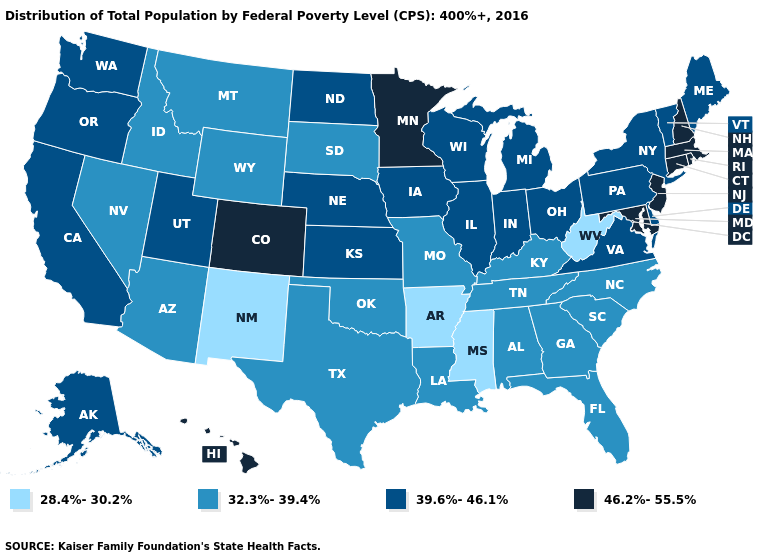How many symbols are there in the legend?
Quick response, please. 4. Among the states that border Colorado , which have the lowest value?
Give a very brief answer. New Mexico. What is the highest value in states that border Nebraska?
Be succinct. 46.2%-55.5%. Name the states that have a value in the range 46.2%-55.5%?
Concise answer only. Colorado, Connecticut, Hawaii, Maryland, Massachusetts, Minnesota, New Hampshire, New Jersey, Rhode Island. Among the states that border Wyoming , which have the lowest value?
Keep it brief. Idaho, Montana, South Dakota. Which states have the highest value in the USA?
Concise answer only. Colorado, Connecticut, Hawaii, Maryland, Massachusetts, Minnesota, New Hampshire, New Jersey, Rhode Island. Among the states that border Vermont , does New York have the lowest value?
Short answer required. Yes. What is the lowest value in the USA?
Give a very brief answer. 28.4%-30.2%. What is the lowest value in the USA?
Write a very short answer. 28.4%-30.2%. What is the value of New Hampshire?
Concise answer only. 46.2%-55.5%. Which states have the highest value in the USA?
Short answer required. Colorado, Connecticut, Hawaii, Maryland, Massachusetts, Minnesota, New Hampshire, New Jersey, Rhode Island. What is the value of Louisiana?
Quick response, please. 32.3%-39.4%. Does the map have missing data?
Concise answer only. No. Among the states that border Arkansas , which have the lowest value?
Short answer required. Mississippi. What is the value of Maine?
Write a very short answer. 39.6%-46.1%. 